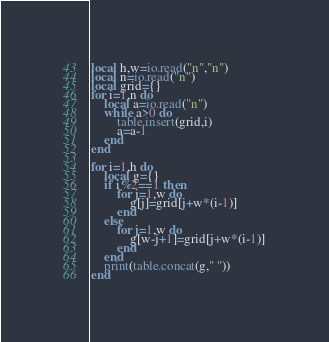<code> <loc_0><loc_0><loc_500><loc_500><_Lua_>local h,w=io.read("n","n")
local n=io.read("n")
local grid={}
for i=1,n do
    local a=io.read("n")
    while a>0 do
        table.insert(grid,i)
        a=a-1
    end
end

for i=1,h do
    local g={}
    if i%2==1 then
        for j=1,w do
            g[j]=grid[j+w*(i-1)]
        end
    else
        for j=1,w do
            g[w-j+1]=grid[j+w*(i-1)]
        end
    end
    print(table.concat(g," "))
end</code> 